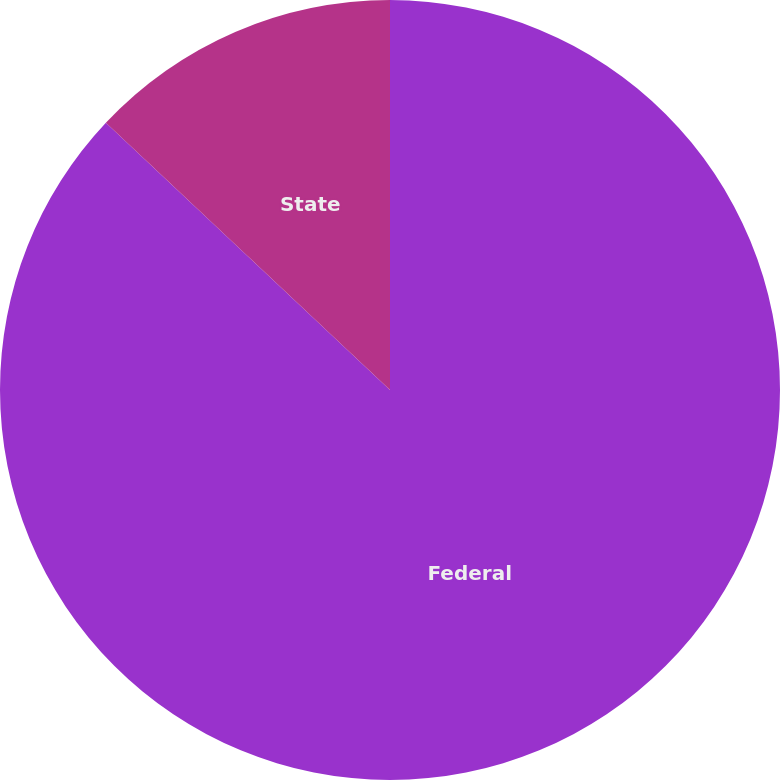Convert chart. <chart><loc_0><loc_0><loc_500><loc_500><pie_chart><fcel>Federal<fcel>State<nl><fcel>87.01%<fcel>12.99%<nl></chart> 